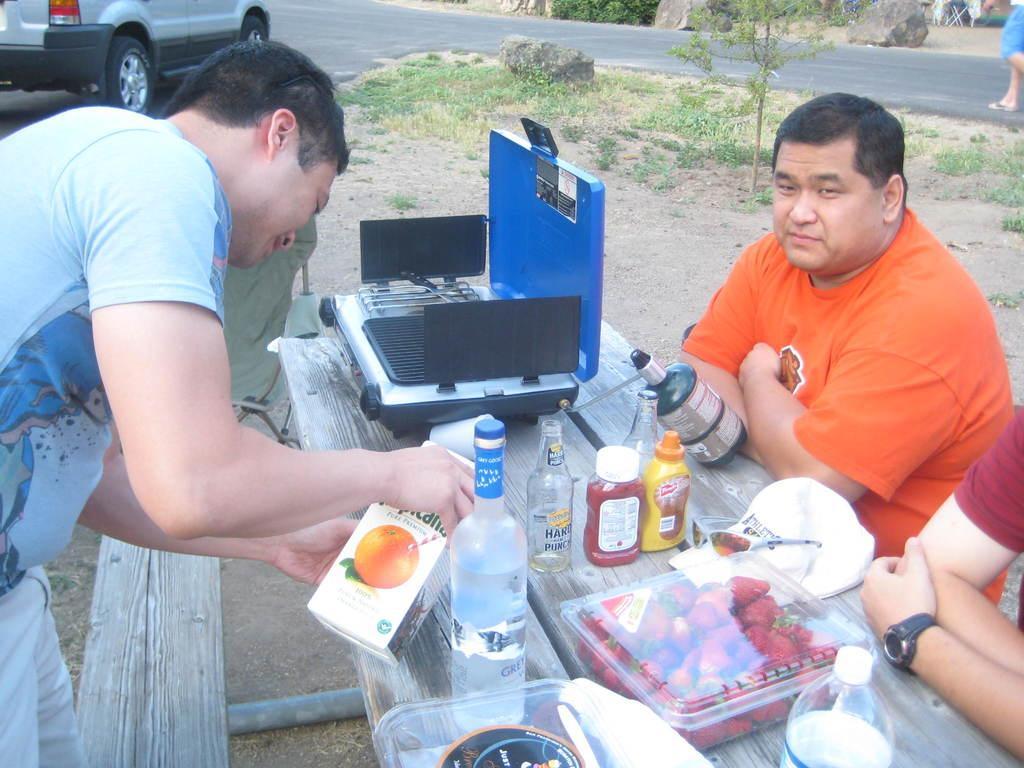In one or two sentences, can you explain what this image depicts? In this image I can see a person wearing blue colored t shirt and white color pant is standing and holding a box in his hands. I can see few persons are sitting on bench and on the bench I can see few bottles, a box with strawberries in it, goggles and a white colored hat. In the background I can see the road, a person standing on the road, few rocks and a car. 